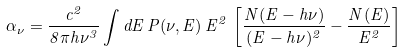<formula> <loc_0><loc_0><loc_500><loc_500>\alpha _ { \nu } = \frac { c ^ { 2 } } { 8 \pi h \nu ^ { 3 } } \int d E \, P ( \nu , E ) \, E ^ { 2 } \, \left [ \frac { N ( E - h \nu ) } { ( E - h \nu ) ^ { 2 } } - \frac { N ( E ) } { E ^ { 2 } } \right ]</formula> 